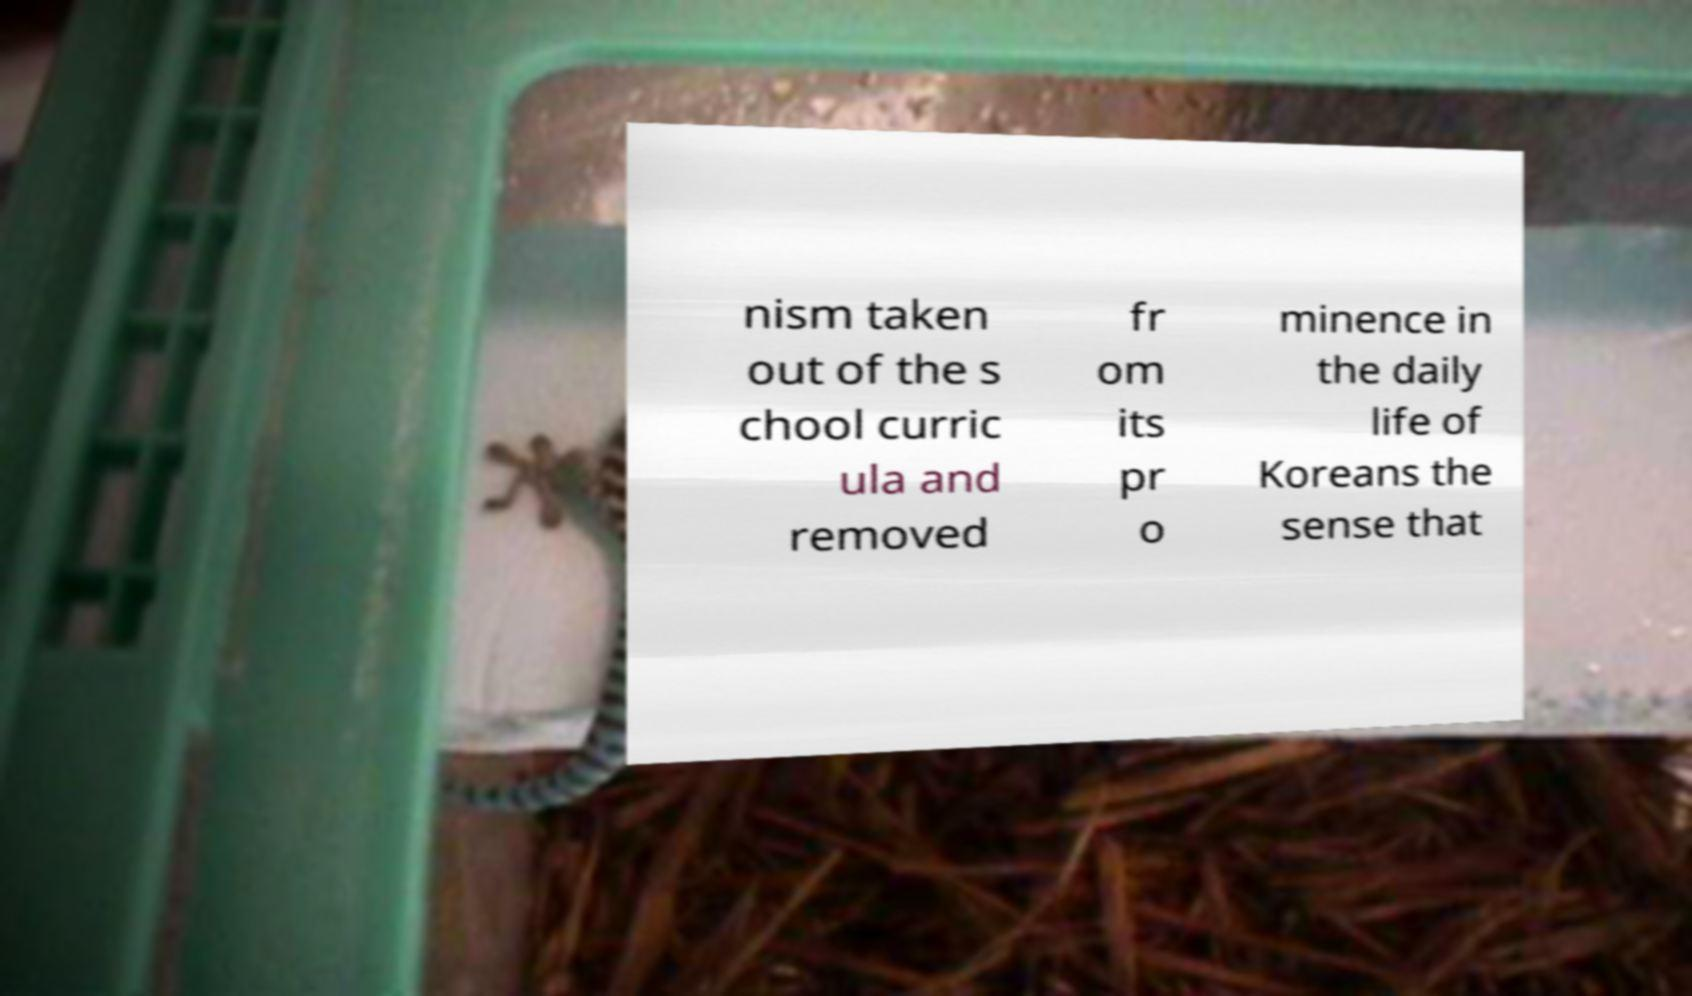Can you read and provide the text displayed in the image?This photo seems to have some interesting text. Can you extract and type it out for me? nism taken out of the s chool curric ula and removed fr om its pr o minence in the daily life of Koreans the sense that 